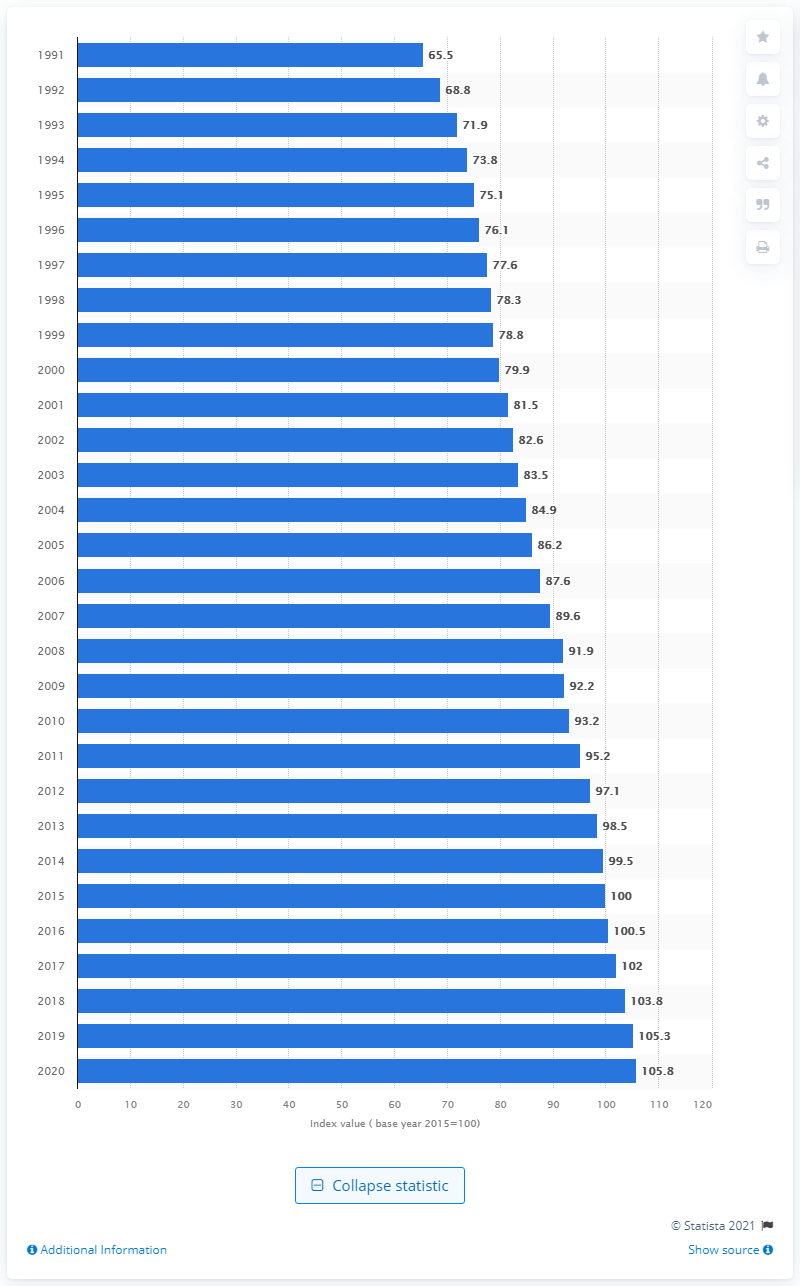Indicate a few pertinent items in this graphic. In 2020, the German Consumer Price Index (CPI) was 105.8. 